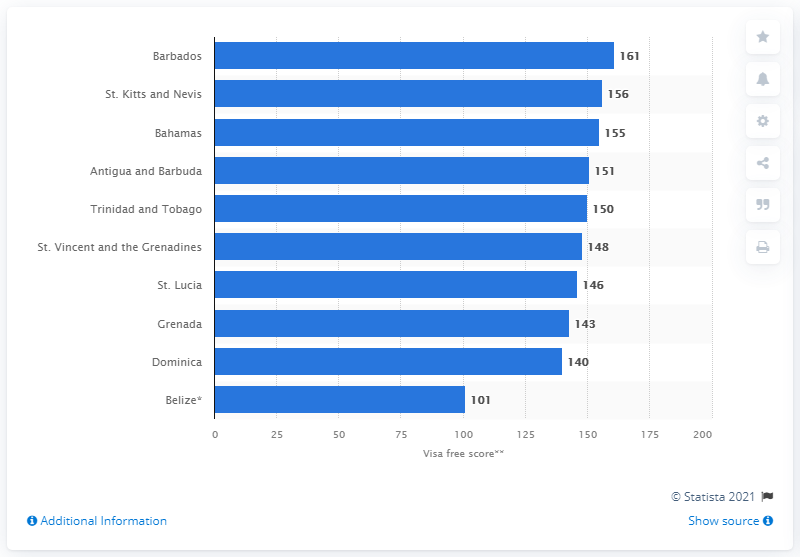Specify some key components in this picture. Barbados was the country that had the most powerful passports in the Caribbean region as of July 2020. The visa-free score of the Barbadian passport is 161. 